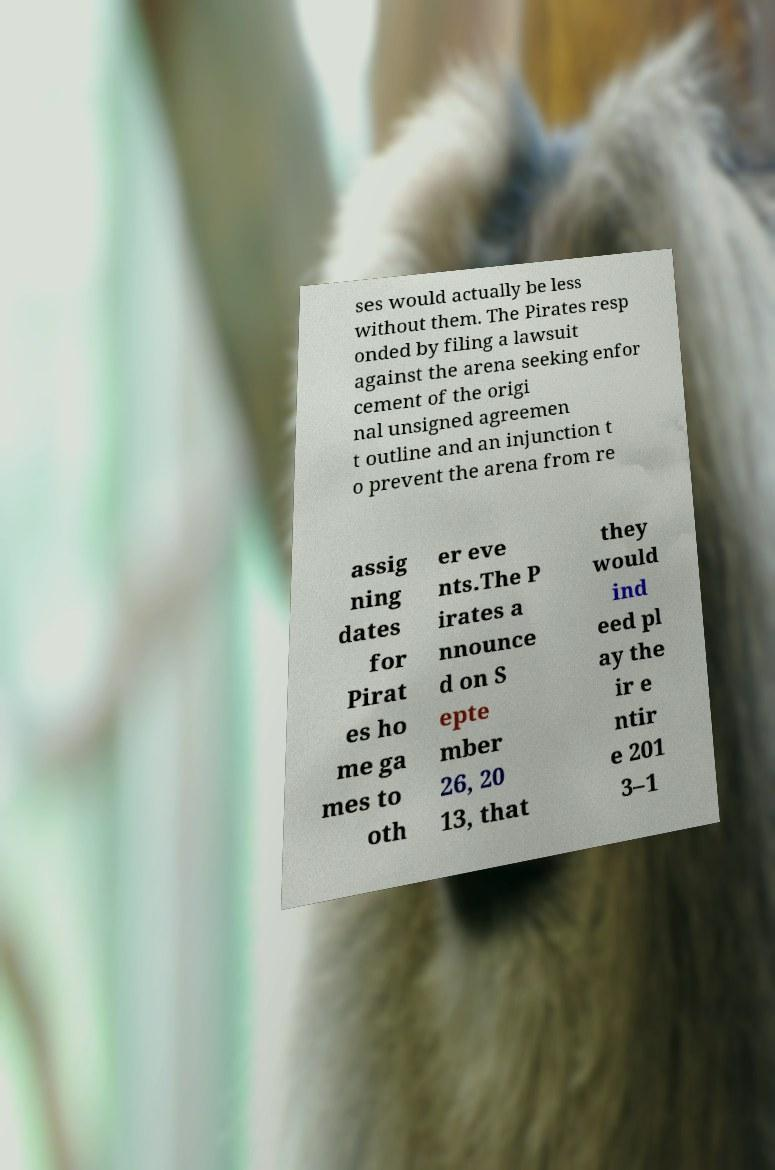Please identify and transcribe the text found in this image. ses would actually be less without them. The Pirates resp onded by filing a lawsuit against the arena seeking enfor cement of the origi nal unsigned agreemen t outline and an injunction t o prevent the arena from re assig ning dates for Pirat es ho me ga mes to oth er eve nts.The P irates a nnounce d on S epte mber 26, 20 13, that they would ind eed pl ay the ir e ntir e 201 3–1 